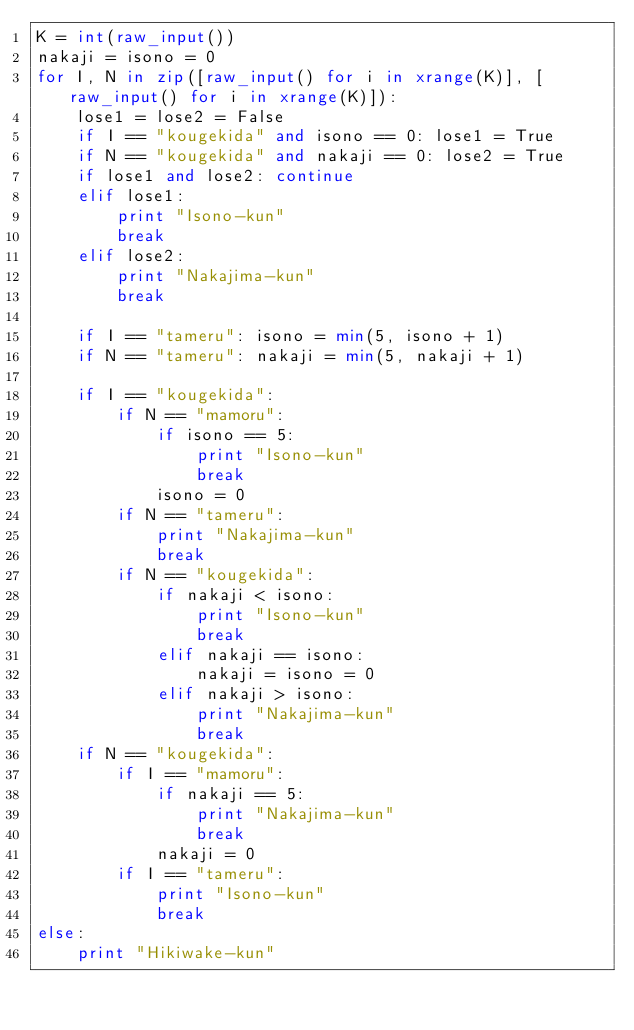<code> <loc_0><loc_0><loc_500><loc_500><_Python_>K = int(raw_input())
nakaji = isono = 0
for I, N in zip([raw_input() for i in xrange(K)], [raw_input() for i in xrange(K)]):
    lose1 = lose2 = False
    if I == "kougekida" and isono == 0: lose1 = True
    if N == "kougekida" and nakaji == 0: lose2 = True
    if lose1 and lose2: continue
    elif lose1:
        print "Isono-kun"
        break
    elif lose2:
        print "Nakajima-kun"
        break

    if I == "tameru": isono = min(5, isono + 1)
    if N == "tameru": nakaji = min(5, nakaji + 1)

    if I == "kougekida":
        if N == "mamoru":
            if isono == 5:
                print "Isono-kun"
                break
            isono = 0
        if N == "tameru":
            print "Nakajima-kun"
            break
        if N == "kougekida":
            if nakaji < isono:
                print "Isono-kun"
                break
            elif nakaji == isono:
                nakaji = isono = 0
            elif nakaji > isono:
                print "Nakajima-kun"
                break
    if N == "kougekida":
        if I == "mamoru":
            if nakaji == 5:
                print "Nakajima-kun"
                break
            nakaji = 0
        if I == "tameru":
            print "Isono-kun"
            break
else:
    print "Hikiwake-kun"</code> 